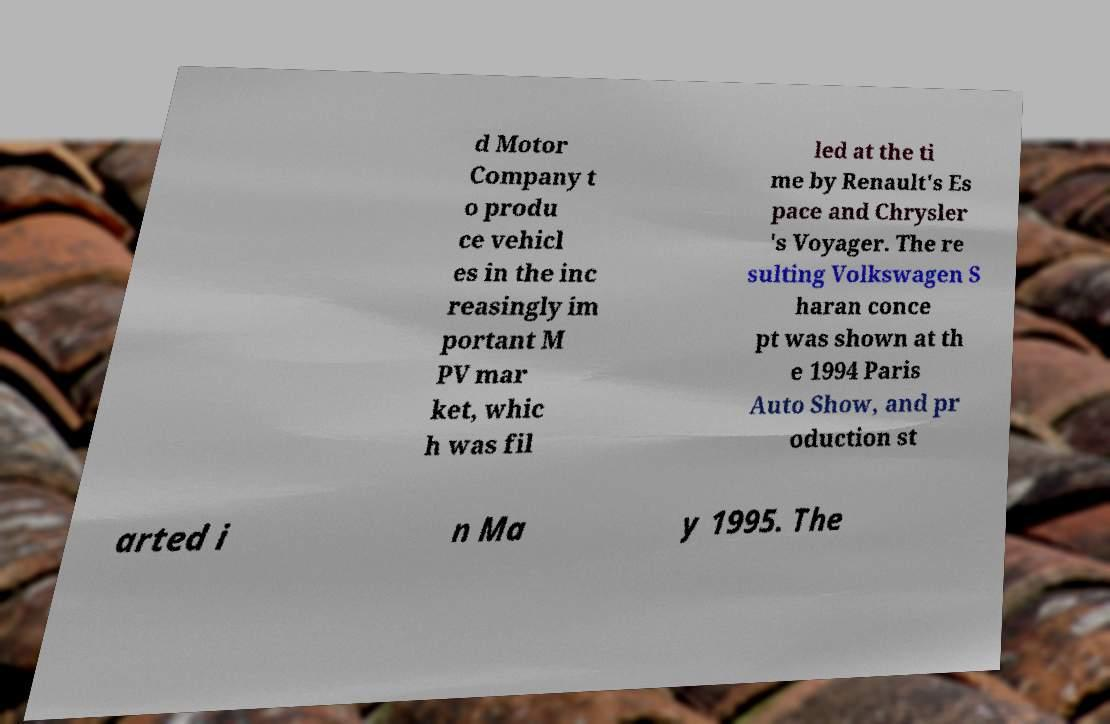Can you accurately transcribe the text from the provided image for me? d Motor Company t o produ ce vehicl es in the inc reasingly im portant M PV mar ket, whic h was fil led at the ti me by Renault's Es pace and Chrysler 's Voyager. The re sulting Volkswagen S haran conce pt was shown at th e 1994 Paris Auto Show, and pr oduction st arted i n Ma y 1995. The 